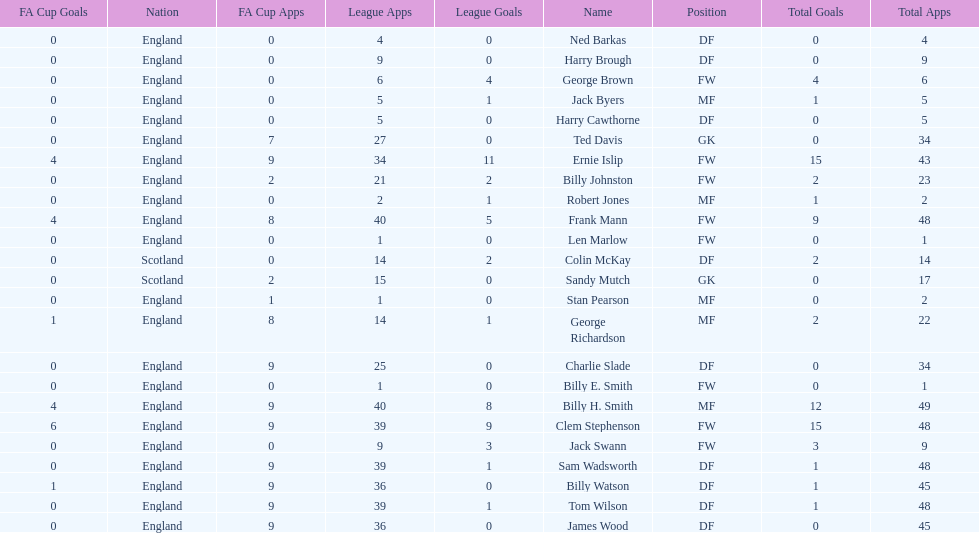Which position is listed the least amount of times on this chart? GK. 